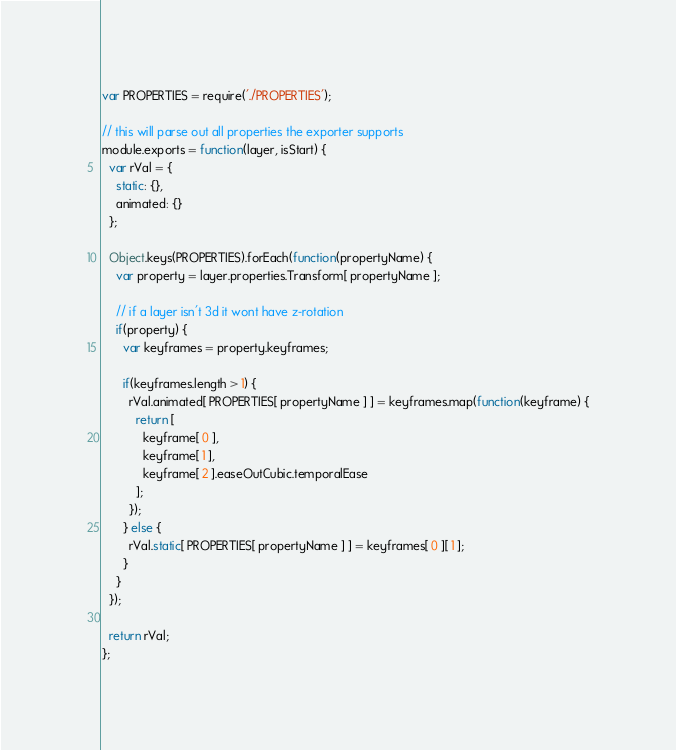Convert code to text. <code><loc_0><loc_0><loc_500><loc_500><_JavaScript_>var PROPERTIES = require('./PROPERTIES');

// this will parse out all properties the exporter supports
module.exports = function(layer, isStart) {
  var rVal = {
    static: {},
    animated: {}
  };
  
  Object.keys(PROPERTIES).forEach(function(propertyName) {
    var property = layer.properties.Transform[ propertyName ];

    // if a layer isn't 3d it wont have z-rotation
    if(property) {
      var keyframes = property.keyframes;

      if(keyframes.length > 1) {
        rVal.animated[ PROPERTIES[ propertyName ] ] = keyframes.map(function(keyframe) {
          return [
            keyframe[ 0 ],
            keyframe[ 1 ],
            keyframe[ 2 ].easeOutCubic.temporalEase
          ];
        });
      } else {
        rVal.static[ PROPERTIES[ propertyName ] ] = keyframes[ 0 ][ 1 ];
      }
    }
  });

  return rVal;
};</code> 